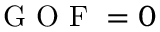Convert formula to latex. <formula><loc_0><loc_0><loc_500><loc_500>G O F = 0</formula> 